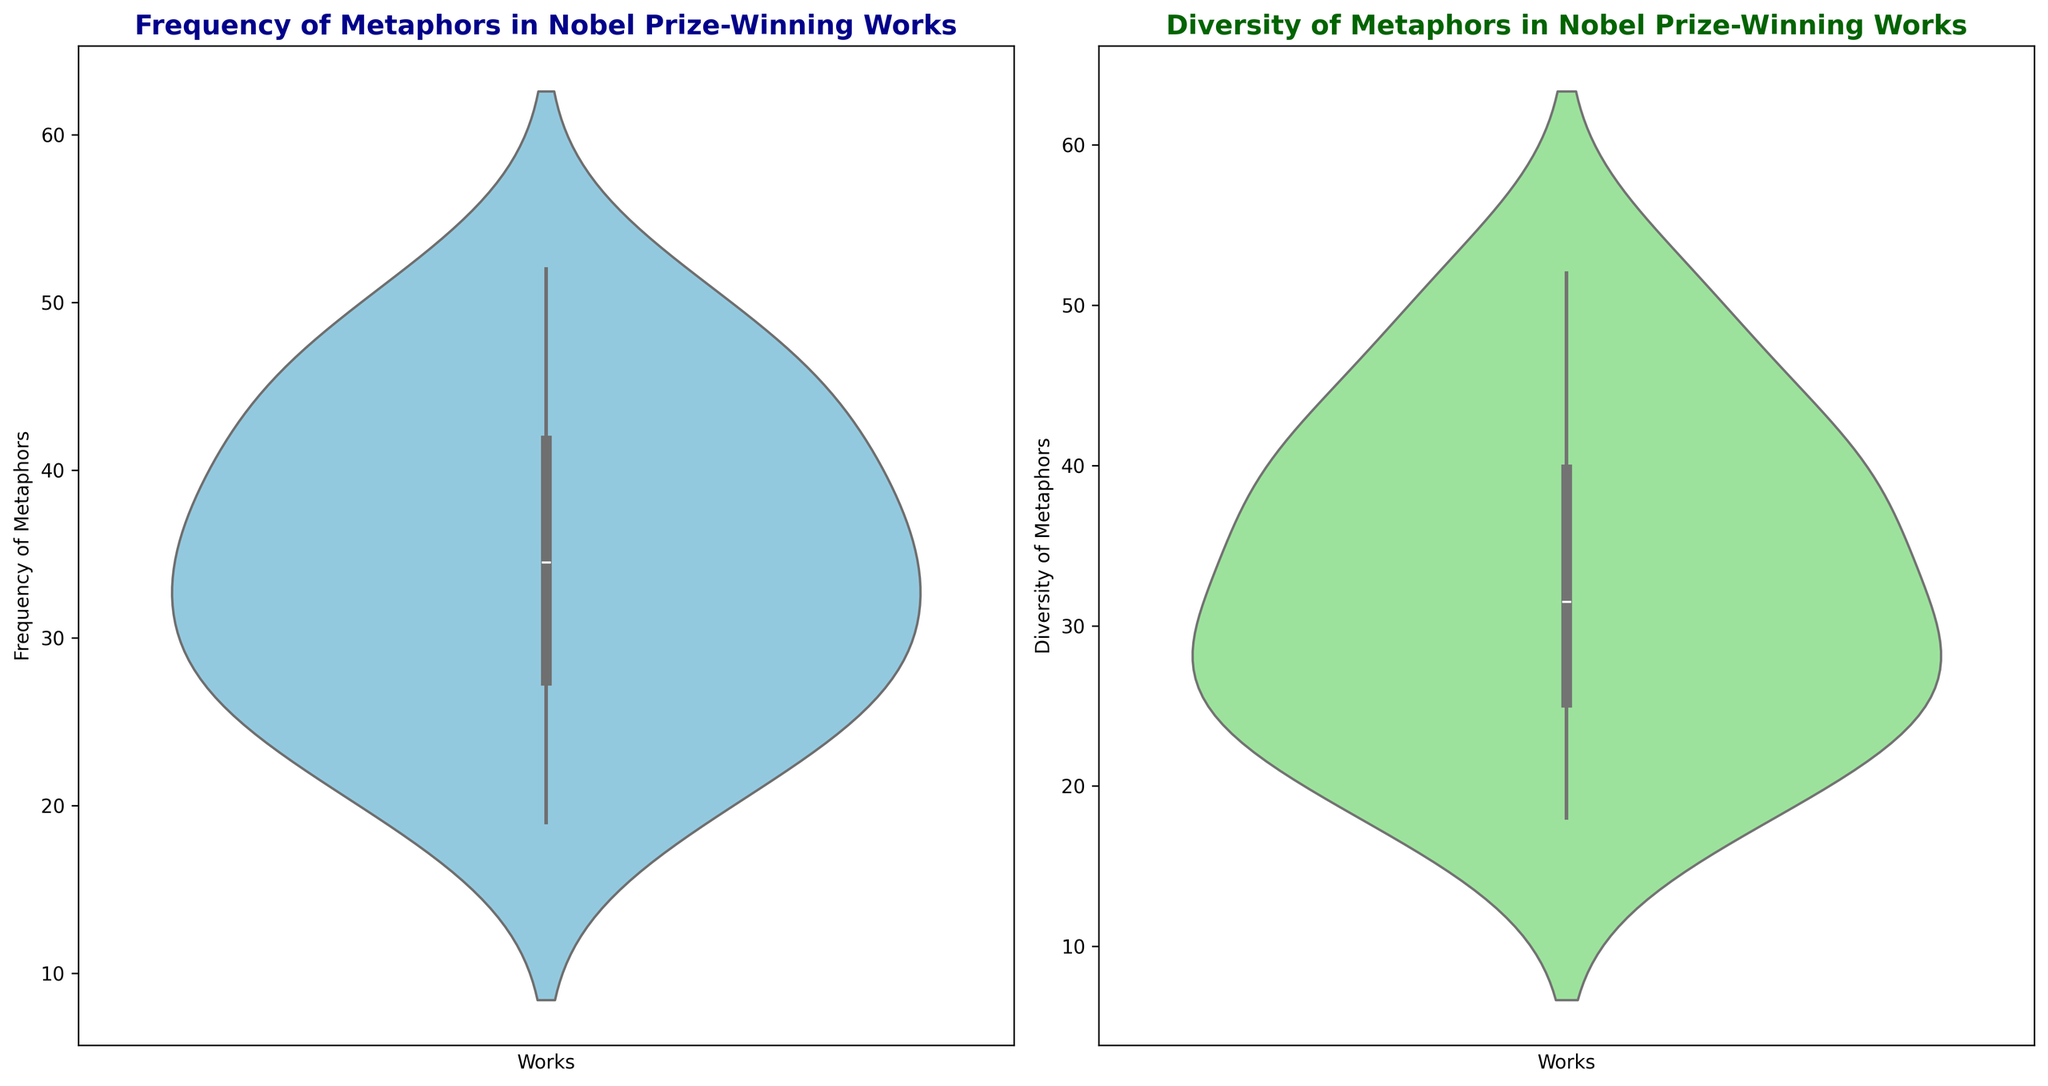What is the median value for the frequency of metaphors? To find the median value for the frequency of metaphors, arrange the values in ascending order and find the middle value. With 17 works: (19, 22, 25, 26, 27, 29, 30, 33, 34, 35, 37, 38, 41, 42, 45, 46, 48), the middle value is the 9th one.
Answer: 34 Which work has the highest diversity of metaphors? By examining the diversity violin plot, the highest point represents the maximum value. From the data, "The Age of Innocence" has the highest diversity with 52 metaphors.
Answer: "The Age of Innocence" Which has a higher frequency, the work with the lowest or highest diversity of metaphors? The work with the highest diversity ("The Age of Innocence", 52) and the work with the lowest diversity ("A Man in Love", 18). Frequencies are 25 and 22 respectively.
Answer: The work with the highest diversity What is the average diversity of metaphors across the works? Sum all diversity values: (35 + 28 + 50 + 40 + 30 + 20 + 25 + 18 + 39 + 26 + 45 + 22 + 38 + 30 + 42 + 52 + 33 + 24) = 597, then divide by the number of works (17). 597 / 17 ≈ 35.12
Answer: 35.12 Between "1982" and "1993", which year had a work with higher frequency of metaphors? Check the frequency values for 1982 ("One Hundred Years of Solitude" 45) and 1993 ("Beloved" 52) in the frequency plot.
Answer: 1993 What is the range of the frequency of metaphors in the given works? The range is the difference between the maximum and minimum value for the frequency. Max value is 52 ("Beloved"), min value is 19 ("The Impostor"). Range: 52 - 19 = 33.
Answer: 33 Is the distribution of diversity of metaphors more spread out or tightly packed compared to the frequency of metaphors? Check the width of the violin plots. The diversity plot is visibly spread out indicating more variance in diversity compared to the frequency.
Answer: More spread out What percentage of works have a frequency of metaphors above 40? Out of 17 works, the counts of frequencies above 40 are ("Beloved" - 52, "One Hundred Years of Solitude" - 45, "Snow" - 46, "The History of Love" - 42, "The Tin Drum" - 48, "A Dance to the Music of Time" - 41). So, 6 out of 17. Percentage: (6 / 17) * 100 ≈ 35.29%
Answer: 35.29% 